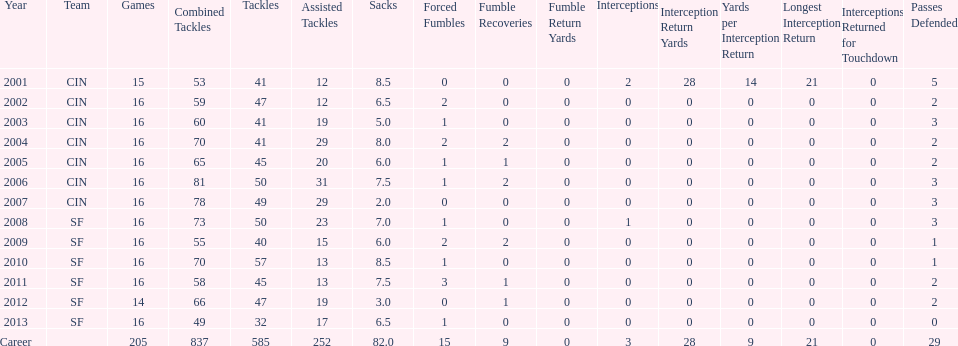How many continuous years had 20 or more assisted tackles? 5. 